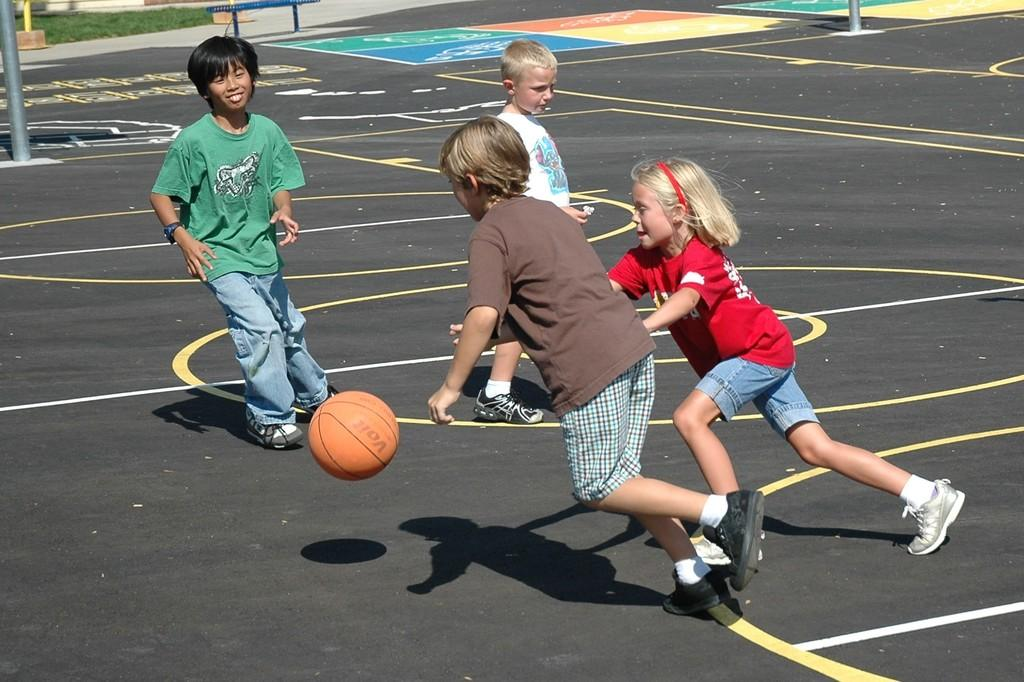What activity are the children engaged in within the image? The children are playing basketball in the image. What surface are they playing on? There is a basketball court in the image. What structures can be seen in the image? There are poles in the image. What type of seating is present in the image? There is a bench at the top of the image. What part of the governor's speech can be heard in the image? There is no reference to a governor or speech in the image; it features children playing basketball on a court. How does the wind affect the basketball game in the image? The image does not depict any wind or its effects on the basketball game. 